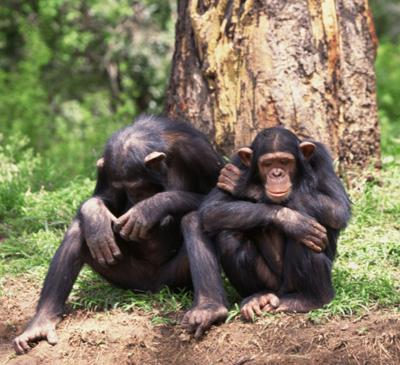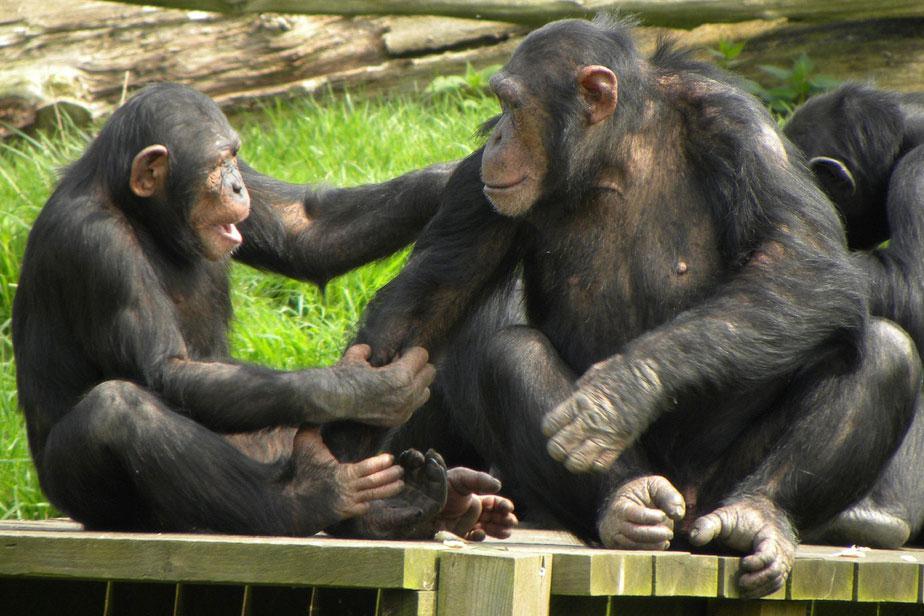The first image is the image on the left, the second image is the image on the right. Analyze the images presented: Is the assertion "There are four chimpanzees." valid? Answer yes or no. No. The first image is the image on the left, the second image is the image on the right. For the images shown, is this caption "One chimpanzee is touching another chimpanzee with both its hands." true? Answer yes or no. Yes. 